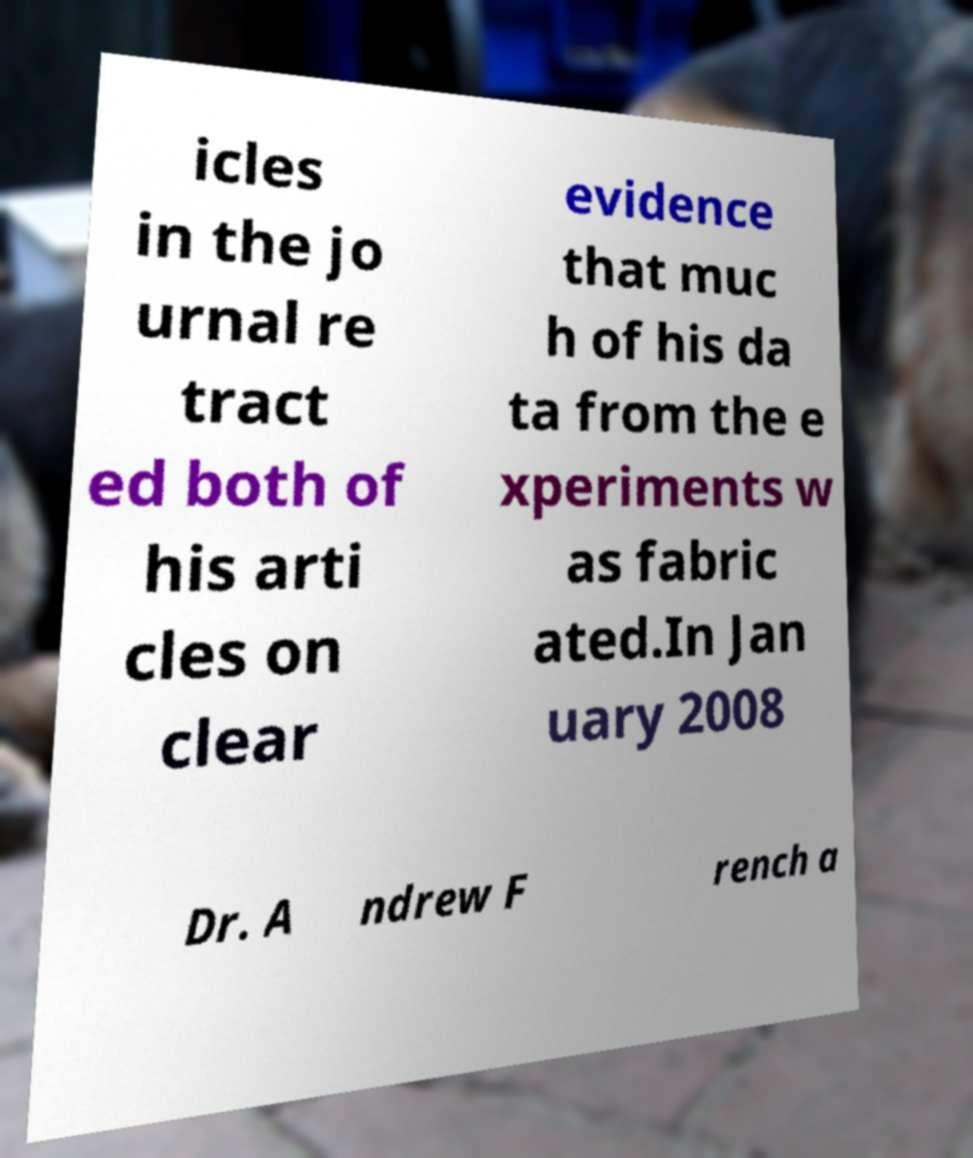What messages or text are displayed in this image? I need them in a readable, typed format. icles in the jo urnal re tract ed both of his arti cles on clear evidence that muc h of his da ta from the e xperiments w as fabric ated.In Jan uary 2008 Dr. A ndrew F rench a 